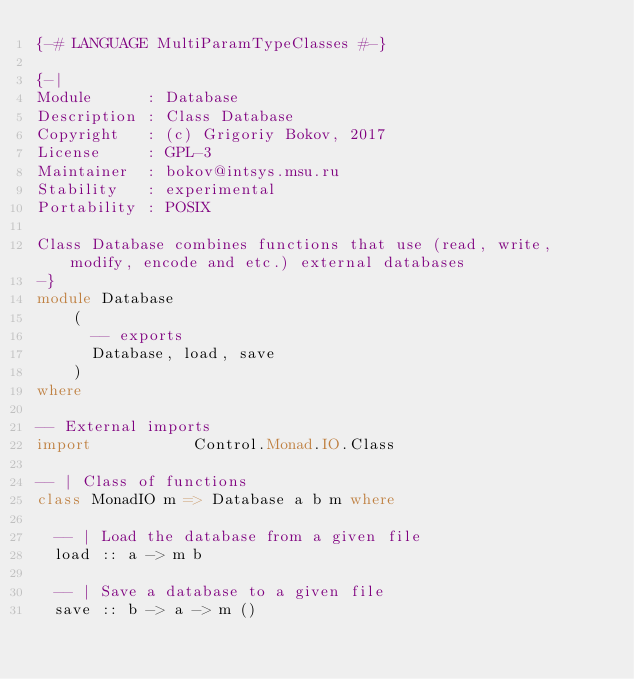Convert code to text. <code><loc_0><loc_0><loc_500><loc_500><_Haskell_>{-# LANGUAGE MultiParamTypeClasses #-}

{-|
Module      : Database
Description : Class Database
Copyright   : (c) Grigoriy Bokov, 2017
License     : GPL-3
Maintainer  : bokov@intsys.msu.ru
Stability   : experimental
Portability : POSIX

Class Database combines functions that use (read, write, modify, encode and etc.) external databases
-}
module Database
    (
      -- exports
      Database, load, save
    )
where

-- External imports
import           Control.Monad.IO.Class

-- | Class of functions
class MonadIO m => Database a b m where

  -- | Load the database from a given file
  load :: a -> m b

  -- | Save a database to a given file
  save :: b -> a -> m ()
</code> 